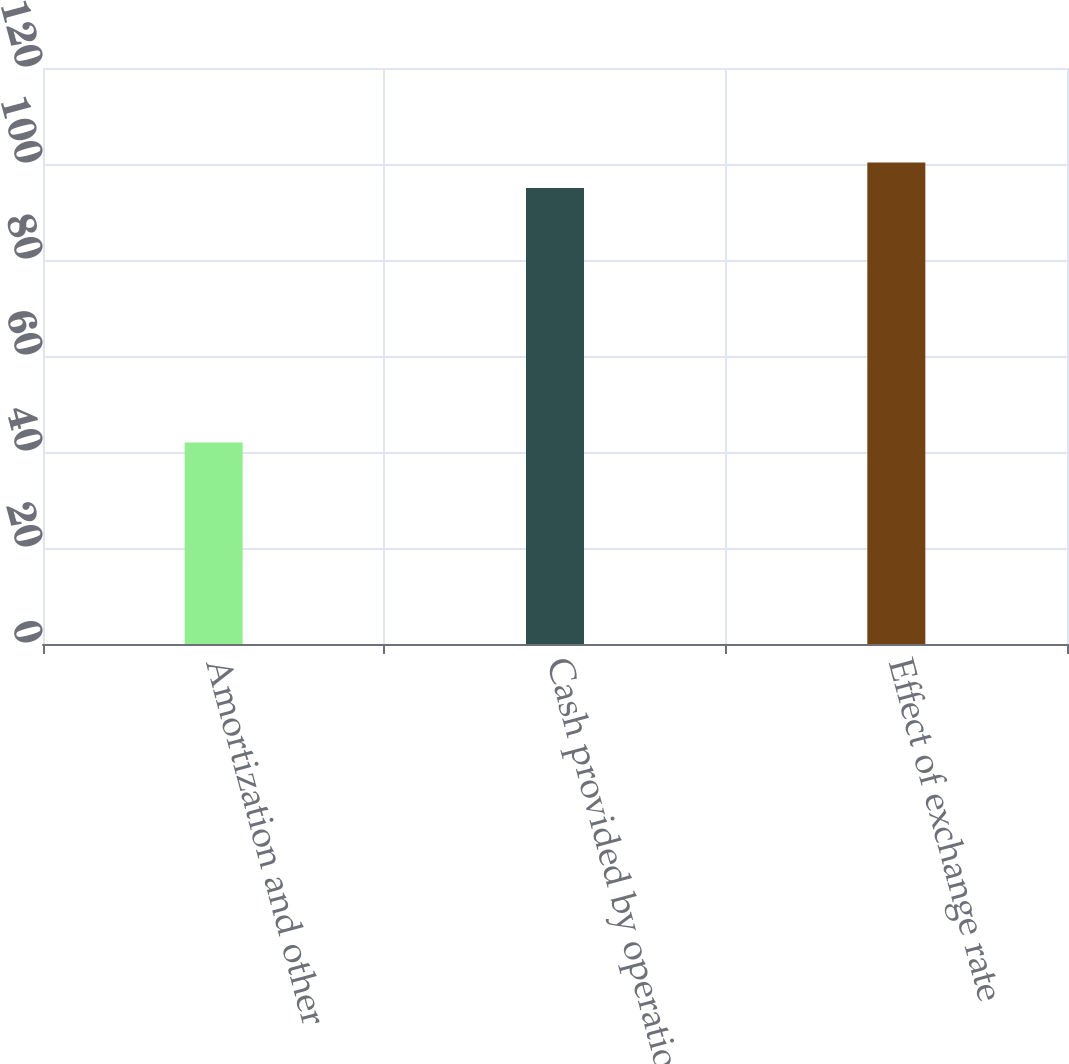Convert chart. <chart><loc_0><loc_0><loc_500><loc_500><bar_chart><fcel>Amortization and other<fcel>Cash provided by operations<fcel>Effect of exchange rate<nl><fcel>42<fcel>95<fcel>100.3<nl></chart> 